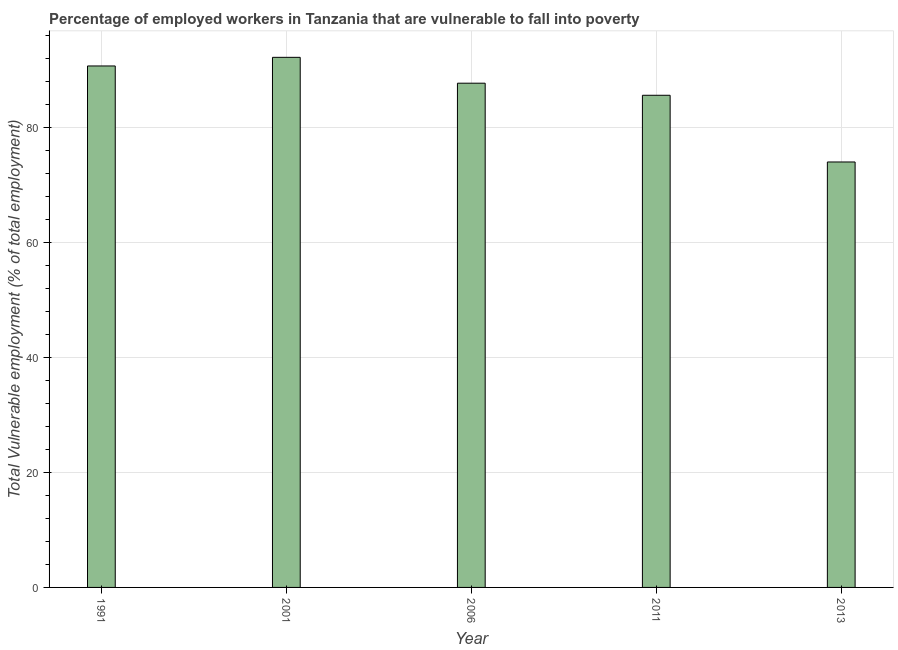Does the graph contain any zero values?
Your response must be concise. No. Does the graph contain grids?
Provide a succinct answer. Yes. What is the title of the graph?
Make the answer very short. Percentage of employed workers in Tanzania that are vulnerable to fall into poverty. What is the label or title of the Y-axis?
Provide a succinct answer. Total Vulnerable employment (% of total employment). What is the total vulnerable employment in 2001?
Offer a very short reply. 92.2. Across all years, what is the maximum total vulnerable employment?
Give a very brief answer. 92.2. Across all years, what is the minimum total vulnerable employment?
Offer a terse response. 74. In which year was the total vulnerable employment maximum?
Make the answer very short. 2001. In which year was the total vulnerable employment minimum?
Your response must be concise. 2013. What is the sum of the total vulnerable employment?
Your answer should be very brief. 430.2. What is the average total vulnerable employment per year?
Give a very brief answer. 86.04. What is the median total vulnerable employment?
Offer a terse response. 87.7. Do a majority of the years between 1991 and 2011 (inclusive) have total vulnerable employment greater than 68 %?
Offer a very short reply. Yes. What is the ratio of the total vulnerable employment in 1991 to that in 2013?
Keep it short and to the point. 1.23. Is the sum of the total vulnerable employment in 1991 and 2001 greater than the maximum total vulnerable employment across all years?
Your answer should be very brief. Yes. What is the difference between the highest and the lowest total vulnerable employment?
Provide a short and direct response. 18.2. How many bars are there?
Offer a very short reply. 5. Are all the bars in the graph horizontal?
Offer a very short reply. No. What is the Total Vulnerable employment (% of total employment) of 1991?
Your answer should be compact. 90.7. What is the Total Vulnerable employment (% of total employment) of 2001?
Your answer should be compact. 92.2. What is the Total Vulnerable employment (% of total employment) in 2006?
Your answer should be very brief. 87.7. What is the Total Vulnerable employment (% of total employment) in 2011?
Your response must be concise. 85.6. What is the difference between the Total Vulnerable employment (% of total employment) in 1991 and 2013?
Make the answer very short. 16.7. What is the difference between the Total Vulnerable employment (% of total employment) in 2001 and 2006?
Make the answer very short. 4.5. What is the difference between the Total Vulnerable employment (% of total employment) in 2006 and 2011?
Give a very brief answer. 2.1. What is the difference between the Total Vulnerable employment (% of total employment) in 2006 and 2013?
Provide a short and direct response. 13.7. What is the ratio of the Total Vulnerable employment (% of total employment) in 1991 to that in 2006?
Your response must be concise. 1.03. What is the ratio of the Total Vulnerable employment (% of total employment) in 1991 to that in 2011?
Your answer should be compact. 1.06. What is the ratio of the Total Vulnerable employment (% of total employment) in 1991 to that in 2013?
Your response must be concise. 1.23. What is the ratio of the Total Vulnerable employment (% of total employment) in 2001 to that in 2006?
Provide a succinct answer. 1.05. What is the ratio of the Total Vulnerable employment (% of total employment) in 2001 to that in 2011?
Ensure brevity in your answer.  1.08. What is the ratio of the Total Vulnerable employment (% of total employment) in 2001 to that in 2013?
Your response must be concise. 1.25. What is the ratio of the Total Vulnerable employment (% of total employment) in 2006 to that in 2013?
Provide a succinct answer. 1.19. What is the ratio of the Total Vulnerable employment (% of total employment) in 2011 to that in 2013?
Provide a short and direct response. 1.16. 